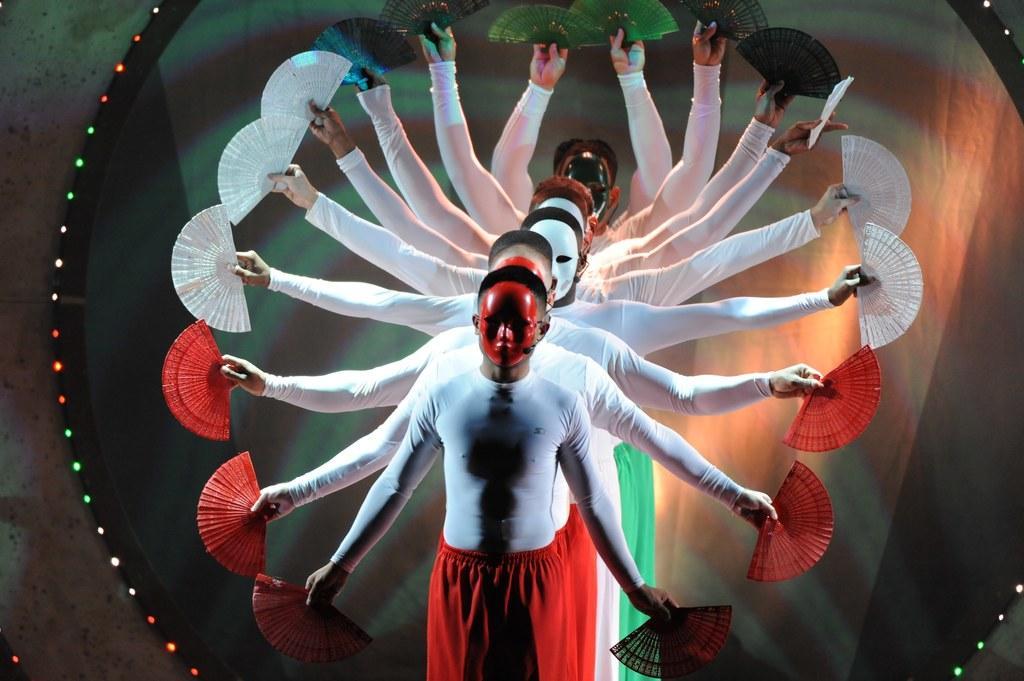Can you describe this image briefly? In the image we can see there are people standing in a queue and they are wearing face mask on their face. They are holding hand fans in their hand and the hand fans are in orange and white colour. They all are wearing white colour t shirt. 